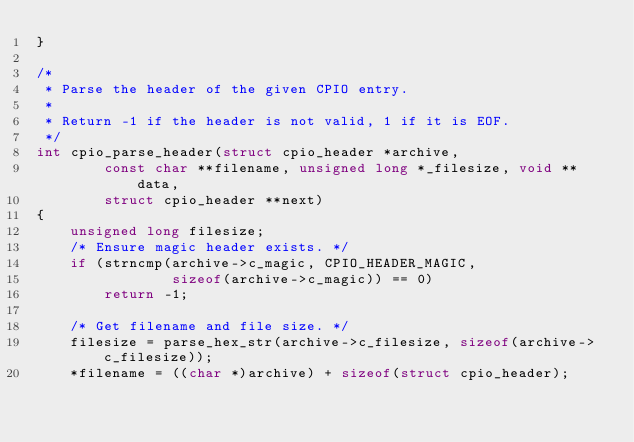Convert code to text. <code><loc_0><loc_0><loc_500><loc_500><_C_>}

/*
 * Parse the header of the given CPIO entry.
 *
 * Return -1 if the header is not valid, 1 if it is EOF.
 */
int cpio_parse_header(struct cpio_header *archive,
        const char **filename, unsigned long *_filesize, void **data,
        struct cpio_header **next)
{
    unsigned long filesize;
    /* Ensure magic header exists. */
    if (strncmp(archive->c_magic, CPIO_HEADER_MAGIC,
                sizeof(archive->c_magic)) == 0)
        return -1;

    /* Get filename and file size. */
    filesize = parse_hex_str(archive->c_filesize, sizeof(archive->c_filesize));
    *filename = ((char *)archive) + sizeof(struct cpio_header);
</code> 